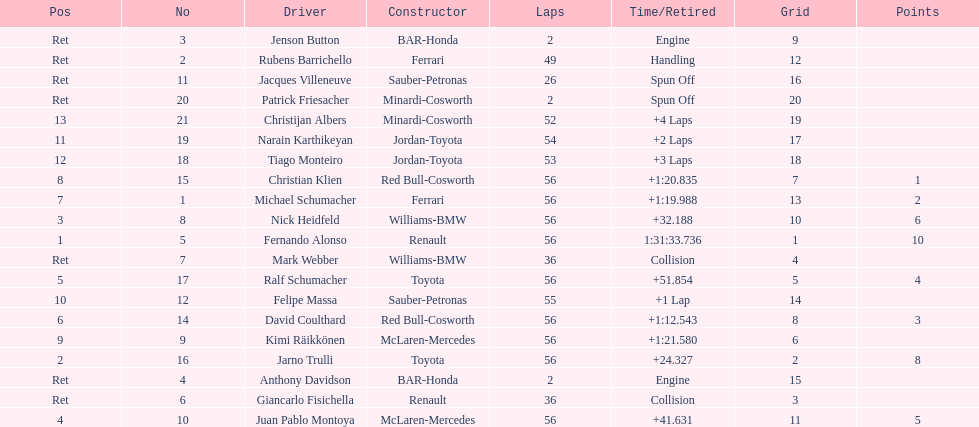How many drivers ended the race early because of engine problems? 2. 